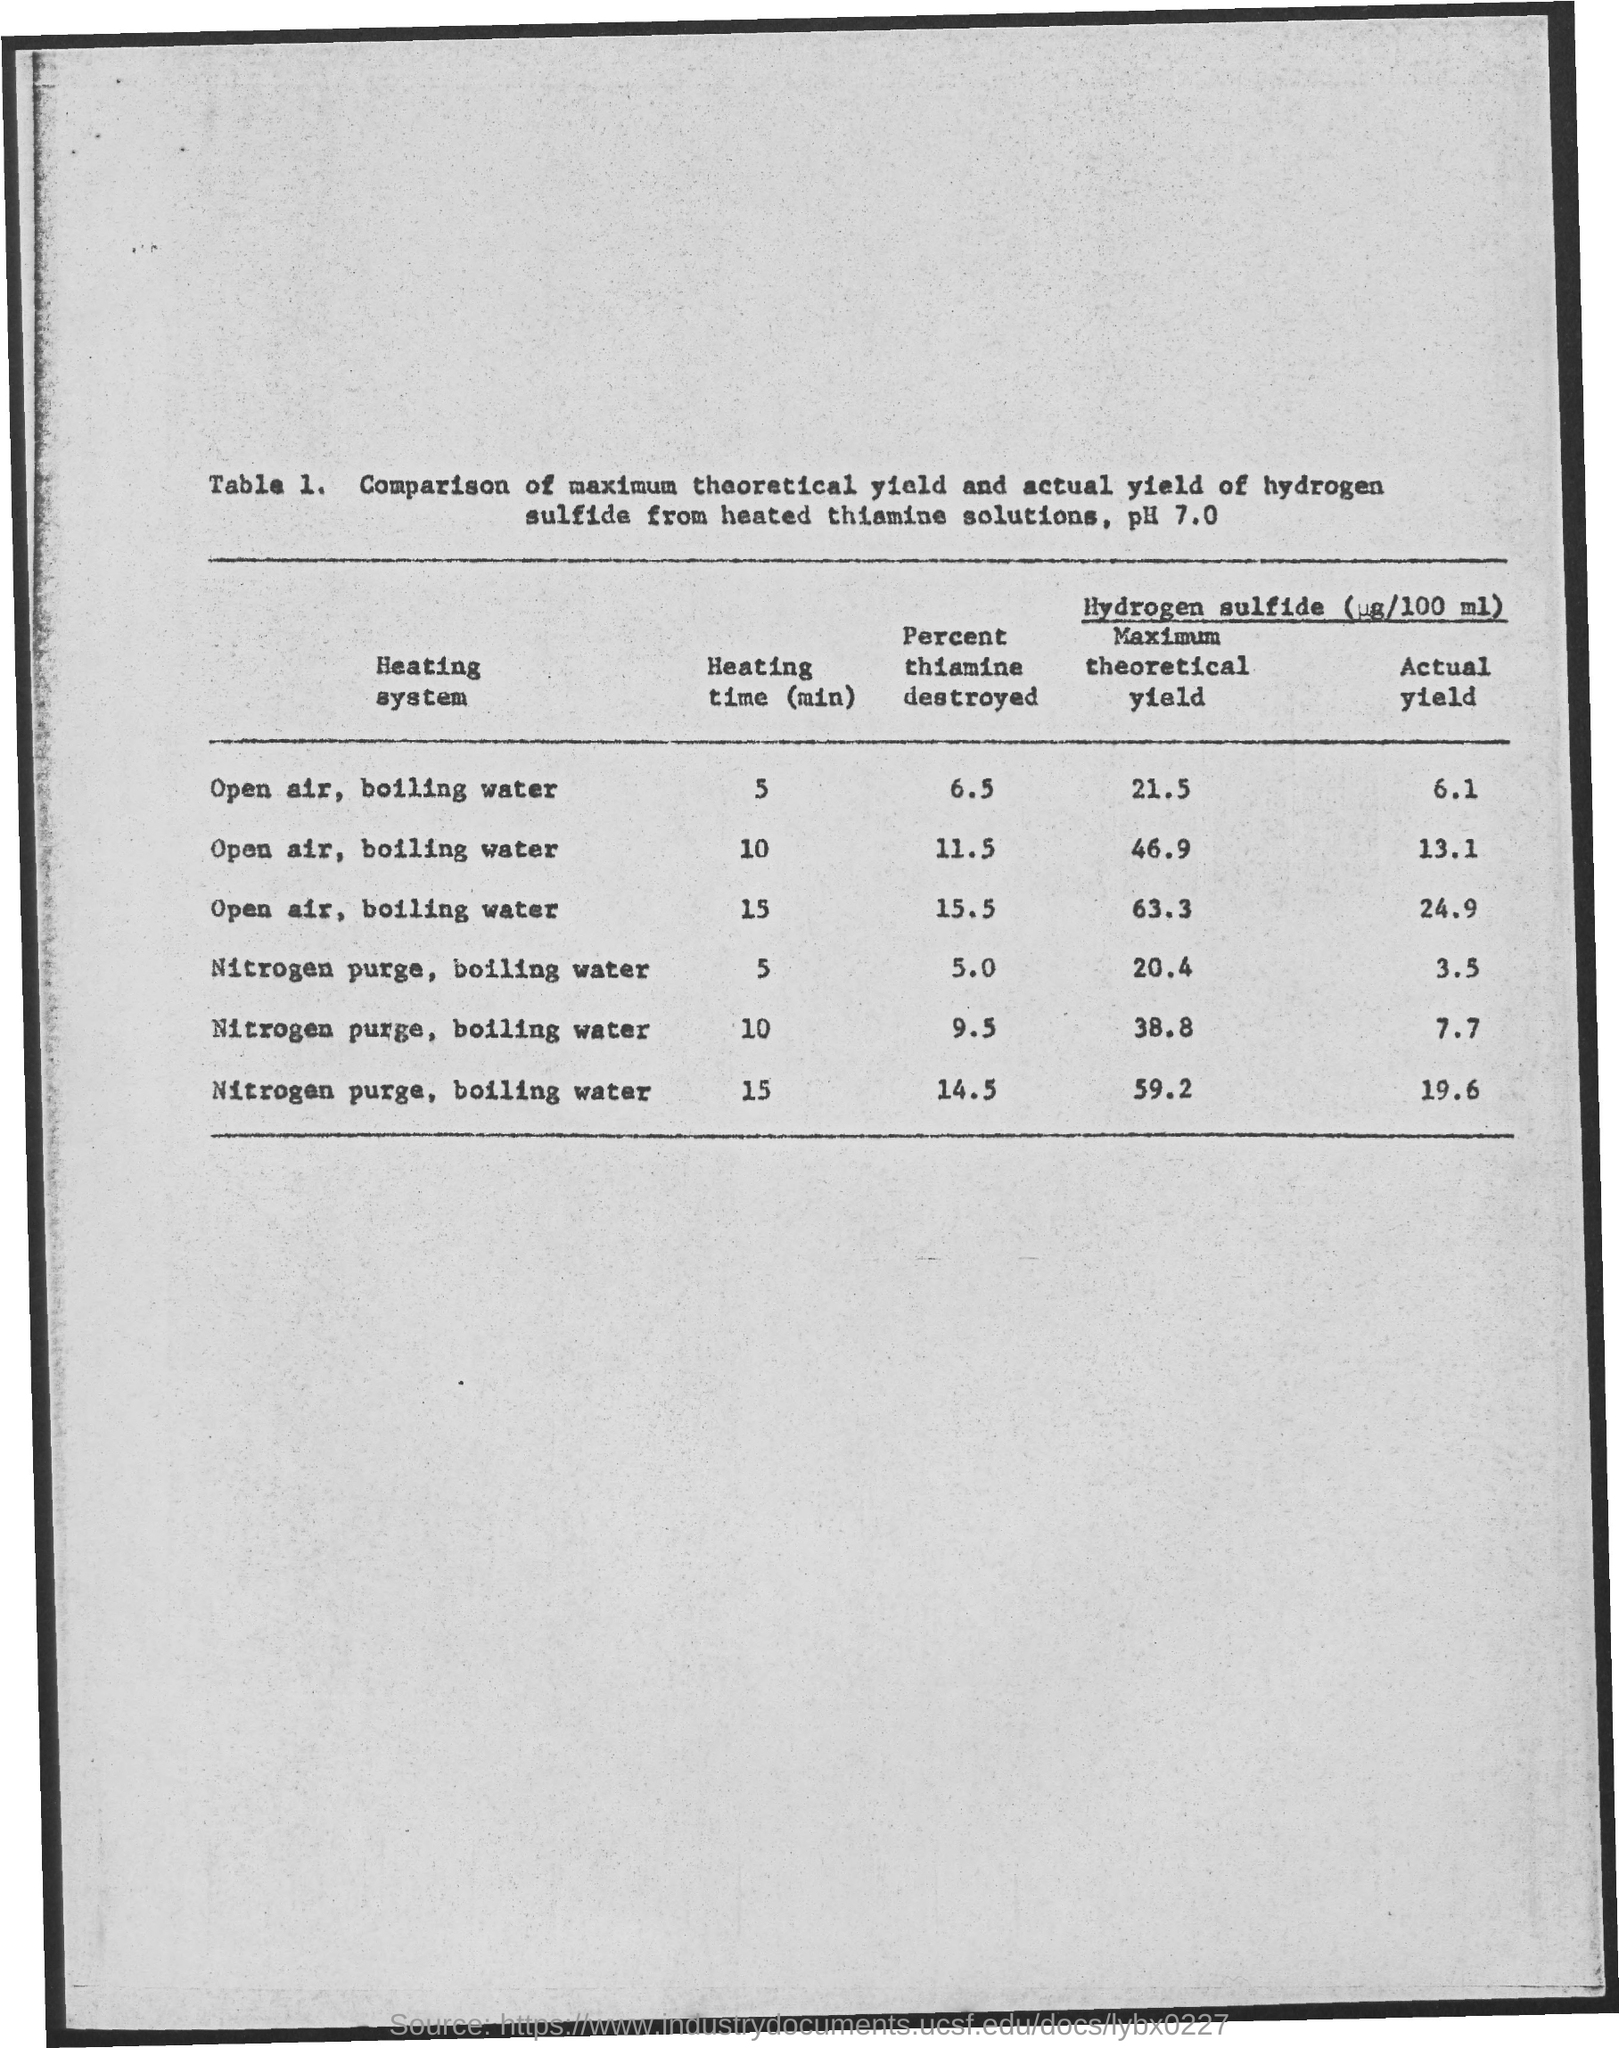Mention a couple of crucial points in this snapshot. The actual yield value for the heating time of 10 minutes in a nitrogen purge and boiling water heating system is 7.7. In the heating system of nitrogen purge, boiling water is used to destroy thiamine for a heating time of 15 minutes. During this process, 14.5% of thiamine is destroyed. During the heating of boiling water in an open air system, approximately 6.5% of thiamine is destroyed after a heating time of 5 minutes. In an open-air heating system, when boiling water is heated for 10 minutes, approximately 11.5% of thiamine is destroyed. The maximum theoretical yield for the heating of open air and boiling water for 5 minutes is 21.5. 